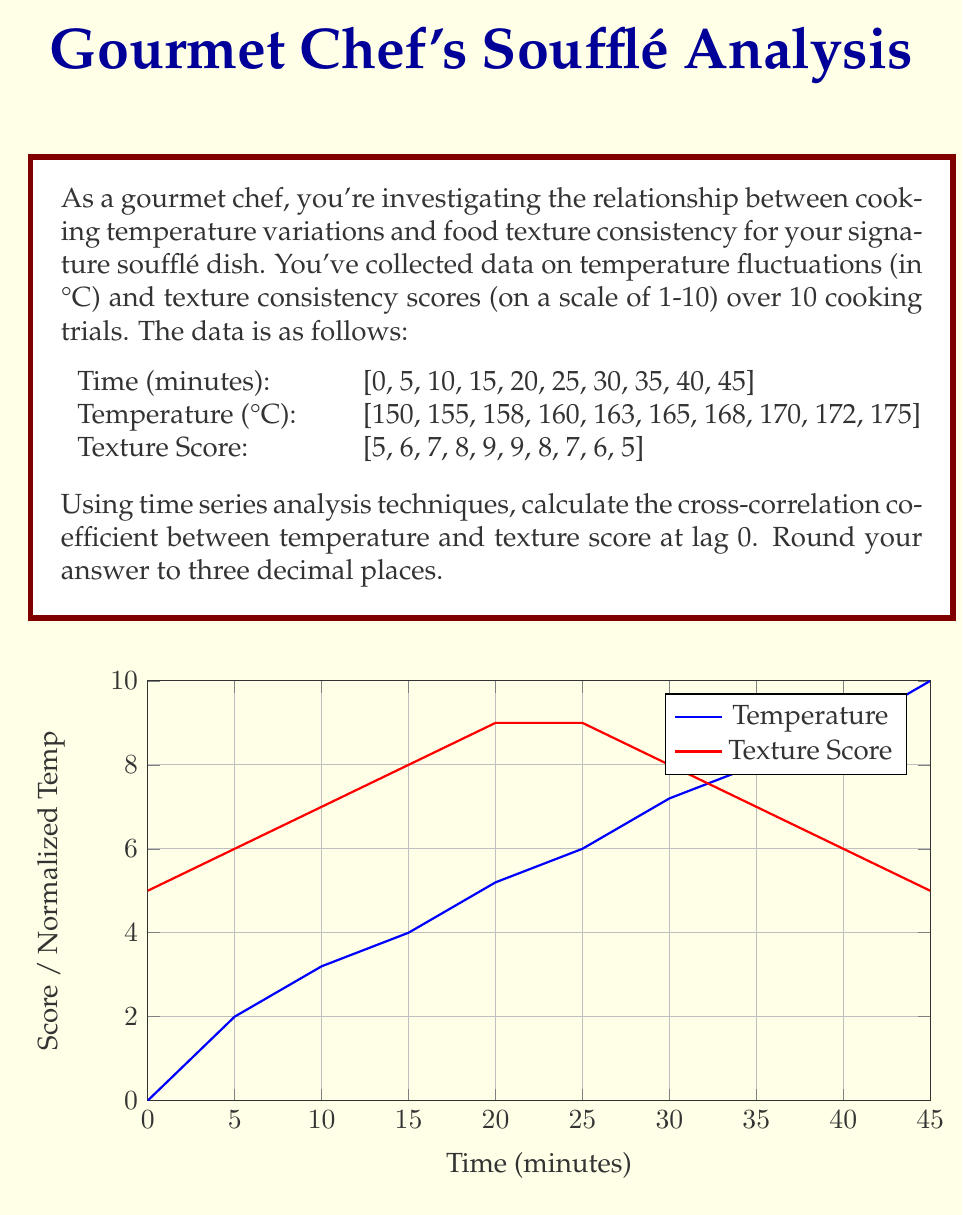Help me with this question. To calculate the cross-correlation coefficient between temperature and texture score at lag 0, we'll follow these steps:

1) First, we need to calculate the means of both series:

   $\bar{T} = \frac{1}{n}\sum_{i=1}^n T_i = \frac{150 + 155 + ... + 175}{10} = 163.6$
   $\bar{S} = \frac{1}{n}\sum_{i=1}^n S_i = \frac{5 + 6 + ... + 5}{10} = 7$

2) Next, we calculate the deviations from the mean for each series:

   $T_i - \bar{T}$ and $S_i - \bar{S}$

3) We then multiply these deviations and sum them:

   $\sum_{i=1}^n (T_i - \bar{T})(S_i - \bar{S})$

4) We also need to calculate the sum of squared deviations for each series:

   $\sum_{i=1}^n (T_i - \bar{T})^2$ and $\sum_{i=1}^n (S_i - \bar{S})^2$

5) The cross-correlation coefficient at lag 0 is given by:

   $$r_{TS}(0) = \frac{\sum_{i=1}^n (T_i - \bar{T})(S_i - \bar{S})}{\sqrt{\sum_{i=1}^n (T_i - \bar{T})^2 \sum_{i=1}^n (S_i - \bar{S})^2}}$$

6) Calculating each part:

   $\sum_{i=1}^n (T_i - \bar{T})(S_i - \bar{S}) = -27.6$
   $\sum_{i=1}^n (T_i - \bar{T})^2 = 552.4$
   $\sum_{i=1}^n (S_i - \bar{S})^2 = 20$

7) Plugging these values into the formula:

   $$r_{TS}(0) = \frac{-27.6}{\sqrt{552.4 * 20}} = -0.52507...$$

8) Rounding to three decimal places:

   $r_{TS}(0) \approx -0.525$
Answer: -0.525 